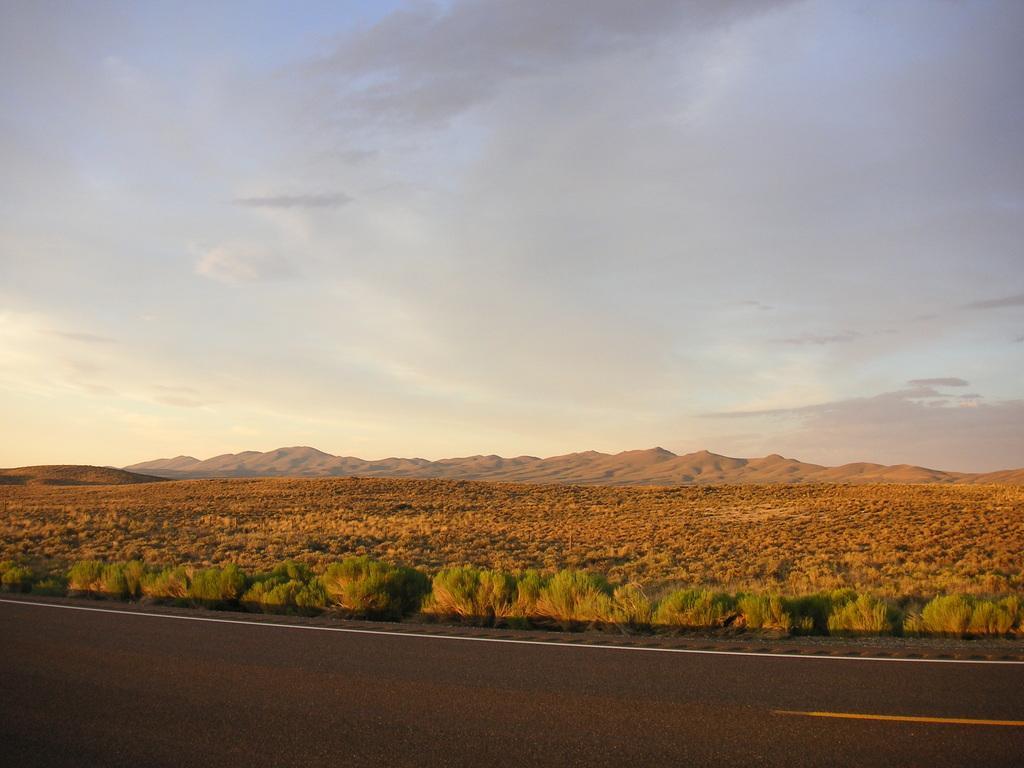Could you give a brief overview of what you see in this image? In this picture we can see mountains, grass and cloudy sky. We can also see plants and roads.   